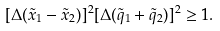Convert formula to latex. <formula><loc_0><loc_0><loc_500><loc_500>[ \Delta ( \tilde { x } _ { 1 } - \tilde { x } _ { 2 } ) ] ^ { 2 } [ \Delta ( \tilde { q } _ { 1 } + \tilde { q } _ { 2 } ) ] ^ { 2 } \geq 1 .</formula> 